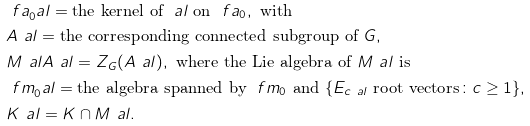<formula> <loc_0><loc_0><loc_500><loc_500>& \ f a _ { 0 } ^ { \ } a l = \text {the kernel of } \ a l \text { on } \ f a _ { 0 } , \text { with } \\ & A ^ { \ } a l = \text {the corresponding connected subgroup of } G , \\ & M ^ { \ } a l A ^ { \ } a l = Z _ { G } ( A ^ { \ } a l ) , \text { where the Lie algebra of } M ^ { \ } a l \text {   is } \\ & \ f m _ { 0 } ^ { \ } a l = \text {the algebra spanned by } \ f m _ { 0 } \text { and  } \{ E _ { c \ a l } \text { root vectors} \colon c \geq 1 \} , \\ & K ^ { \ } a l = K \cap M ^ { \ } a l .</formula> 